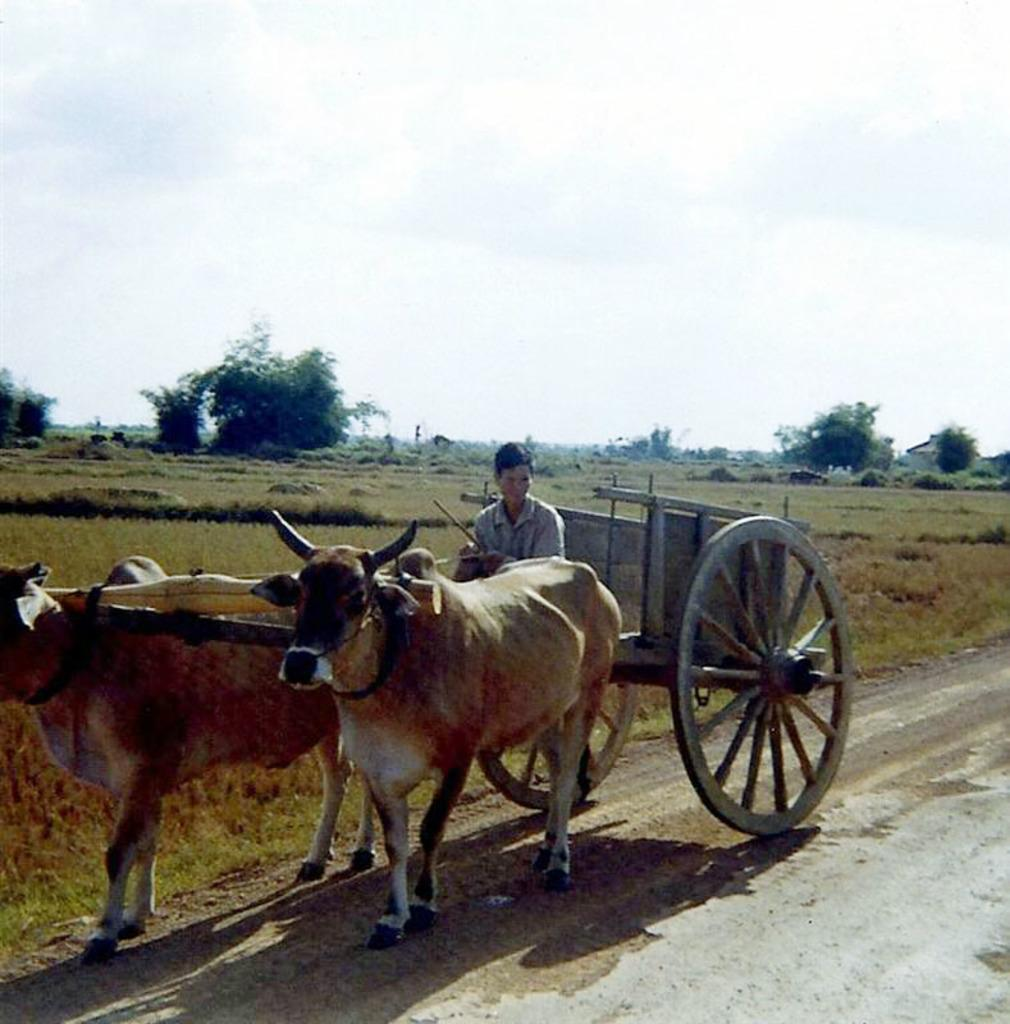Who is the main subject in the image? There is a man in the image. What is the man doing in the image? The man is riding a bullock cart. What type of landscape is visible in the image? There is a land covered with grass in the image. What can be seen in the background of the image? There are trees in the background of the image. Is there a woman riding a bullock cart alongside the man in the image? No, there is no woman present in the image. Can you see any fairies flying around the trees in the background of the image? No, there are no fairies present in the image. 